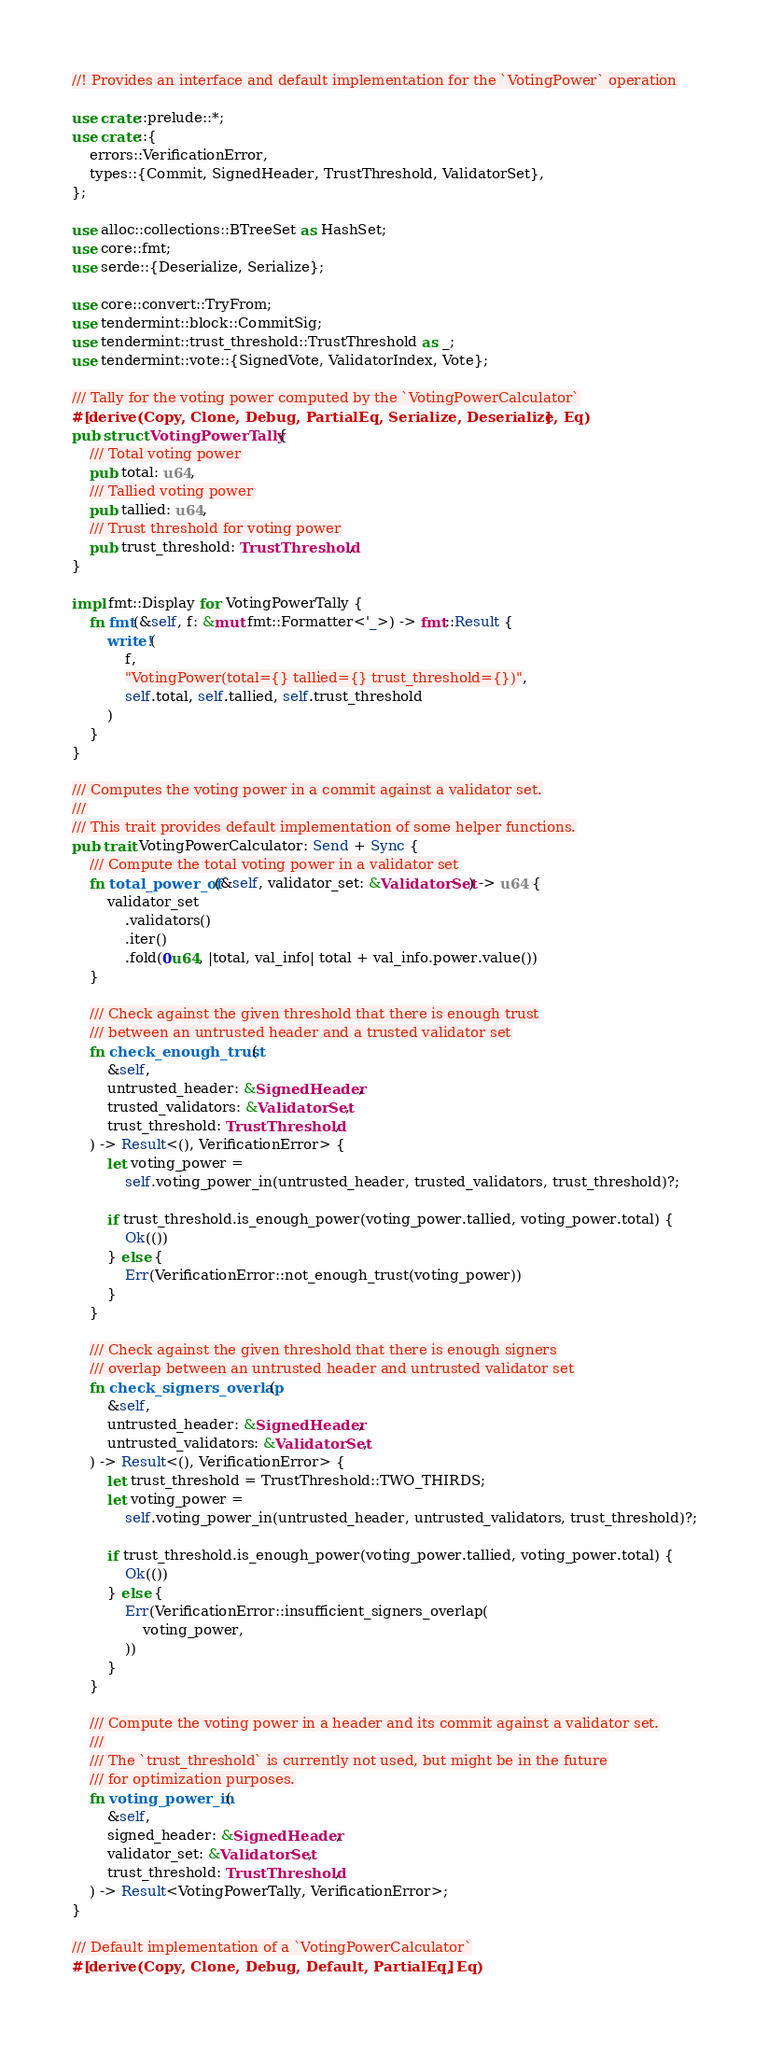Convert code to text. <code><loc_0><loc_0><loc_500><loc_500><_Rust_>//! Provides an interface and default implementation for the `VotingPower` operation

use crate::prelude::*;
use crate::{
    errors::VerificationError,
    types::{Commit, SignedHeader, TrustThreshold, ValidatorSet},
};

use alloc::collections::BTreeSet as HashSet;
use core::fmt;
use serde::{Deserialize, Serialize};

use core::convert::TryFrom;
use tendermint::block::CommitSig;
use tendermint::trust_threshold::TrustThreshold as _;
use tendermint::vote::{SignedVote, ValidatorIndex, Vote};

/// Tally for the voting power computed by the `VotingPowerCalculator`
#[derive(Copy, Clone, Debug, PartialEq, Serialize, Deserialize, Eq)]
pub struct VotingPowerTally {
    /// Total voting power
    pub total: u64,
    /// Tallied voting power
    pub tallied: u64,
    /// Trust threshold for voting power
    pub trust_threshold: TrustThreshold,
}

impl fmt::Display for VotingPowerTally {
    fn fmt(&self, f: &mut fmt::Formatter<'_>) -> fmt::Result {
        write!(
            f,
            "VotingPower(total={} tallied={} trust_threshold={})",
            self.total, self.tallied, self.trust_threshold
        )
    }
}

/// Computes the voting power in a commit against a validator set.
///
/// This trait provides default implementation of some helper functions.
pub trait VotingPowerCalculator: Send + Sync {
    /// Compute the total voting power in a validator set
    fn total_power_of(&self, validator_set: &ValidatorSet) -> u64 {
        validator_set
            .validators()
            .iter()
            .fold(0u64, |total, val_info| total + val_info.power.value())
    }

    /// Check against the given threshold that there is enough trust
    /// between an untrusted header and a trusted validator set
    fn check_enough_trust(
        &self,
        untrusted_header: &SignedHeader,
        trusted_validators: &ValidatorSet,
        trust_threshold: TrustThreshold,
    ) -> Result<(), VerificationError> {
        let voting_power =
            self.voting_power_in(untrusted_header, trusted_validators, trust_threshold)?;

        if trust_threshold.is_enough_power(voting_power.tallied, voting_power.total) {
            Ok(())
        } else {
            Err(VerificationError::not_enough_trust(voting_power))
        }
    }

    /// Check against the given threshold that there is enough signers
    /// overlap between an untrusted header and untrusted validator set
    fn check_signers_overlap(
        &self,
        untrusted_header: &SignedHeader,
        untrusted_validators: &ValidatorSet,
    ) -> Result<(), VerificationError> {
        let trust_threshold = TrustThreshold::TWO_THIRDS;
        let voting_power =
            self.voting_power_in(untrusted_header, untrusted_validators, trust_threshold)?;

        if trust_threshold.is_enough_power(voting_power.tallied, voting_power.total) {
            Ok(())
        } else {
            Err(VerificationError::insufficient_signers_overlap(
                voting_power,
            ))
        }
    }

    /// Compute the voting power in a header and its commit against a validator set.
    ///
    /// The `trust_threshold` is currently not used, but might be in the future
    /// for optimization purposes.
    fn voting_power_in(
        &self,
        signed_header: &SignedHeader,
        validator_set: &ValidatorSet,
        trust_threshold: TrustThreshold,
    ) -> Result<VotingPowerTally, VerificationError>;
}

/// Default implementation of a `VotingPowerCalculator`
#[derive(Copy, Clone, Debug, Default, PartialEq, Eq)]</code> 